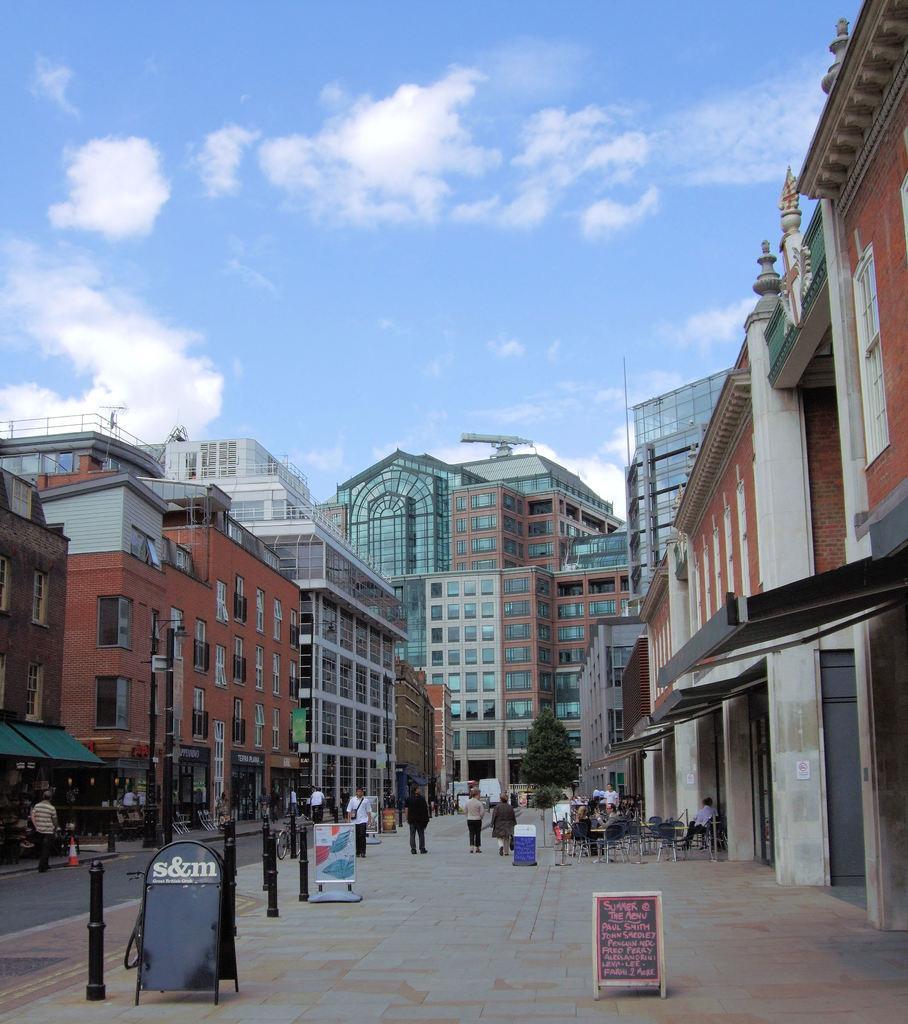Can you describe this image briefly? This picture describe about the the view of the footpath on which a black color dustbin and board is placed. Behind we can see some group of people sitting on the chairs. In the background we can see many glass buildings. 